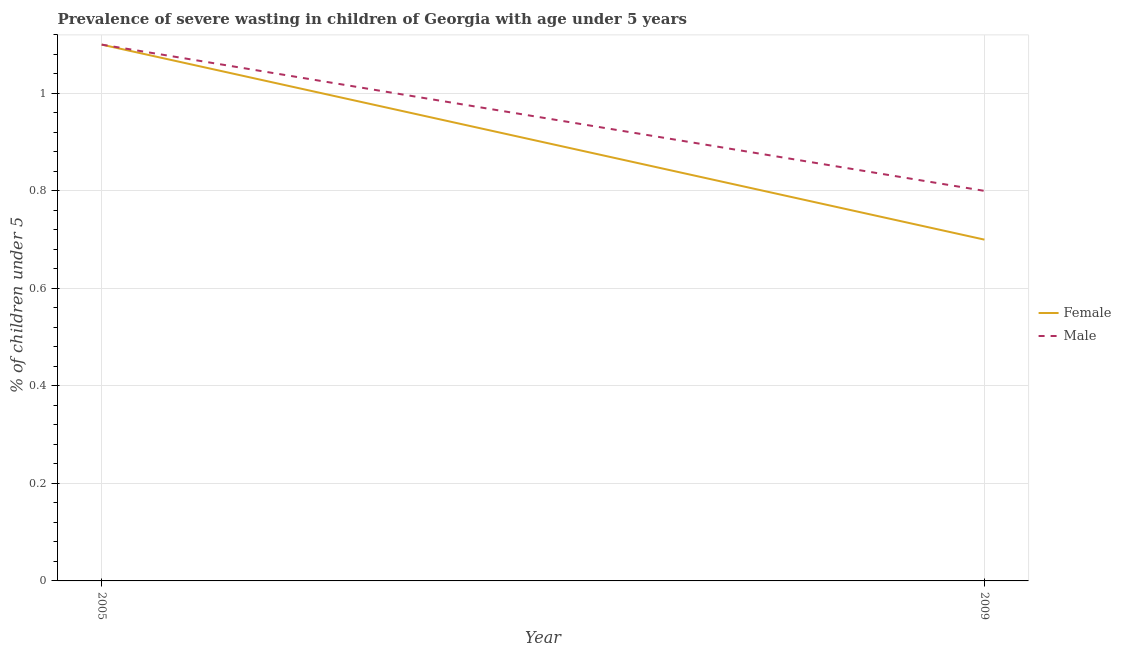How many different coloured lines are there?
Make the answer very short. 2. Does the line corresponding to percentage of undernourished female children intersect with the line corresponding to percentage of undernourished male children?
Provide a short and direct response. Yes. Is the number of lines equal to the number of legend labels?
Your answer should be compact. Yes. What is the percentage of undernourished female children in 2009?
Give a very brief answer. 0.7. Across all years, what is the maximum percentage of undernourished female children?
Make the answer very short. 1.1. Across all years, what is the minimum percentage of undernourished female children?
Provide a short and direct response. 0.7. What is the total percentage of undernourished male children in the graph?
Your answer should be compact. 1.9. What is the difference between the percentage of undernourished female children in 2005 and that in 2009?
Provide a succinct answer. 0.4. What is the difference between the percentage of undernourished female children in 2009 and the percentage of undernourished male children in 2005?
Provide a short and direct response. -0.4. What is the average percentage of undernourished female children per year?
Your answer should be very brief. 0.9. In the year 2005, what is the difference between the percentage of undernourished male children and percentage of undernourished female children?
Give a very brief answer. 0. What is the ratio of the percentage of undernourished male children in 2005 to that in 2009?
Offer a terse response. 1.38. In how many years, is the percentage of undernourished female children greater than the average percentage of undernourished female children taken over all years?
Ensure brevity in your answer.  1. Does the percentage of undernourished male children monotonically increase over the years?
Provide a short and direct response. No. Is the percentage of undernourished male children strictly greater than the percentage of undernourished female children over the years?
Ensure brevity in your answer.  No. How many lines are there?
Offer a terse response. 2. Does the graph contain grids?
Provide a succinct answer. Yes. How many legend labels are there?
Provide a short and direct response. 2. How are the legend labels stacked?
Keep it short and to the point. Vertical. What is the title of the graph?
Keep it short and to the point. Prevalence of severe wasting in children of Georgia with age under 5 years. Does "Largest city" appear as one of the legend labels in the graph?
Offer a very short reply. No. What is the label or title of the X-axis?
Your answer should be compact. Year. What is the label or title of the Y-axis?
Ensure brevity in your answer.   % of children under 5. What is the  % of children under 5 in Female in 2005?
Ensure brevity in your answer.  1.1. What is the  % of children under 5 of Male in 2005?
Keep it short and to the point. 1.1. What is the  % of children under 5 of Female in 2009?
Provide a succinct answer. 0.7. What is the  % of children under 5 in Male in 2009?
Provide a short and direct response. 0.8. Across all years, what is the maximum  % of children under 5 in Female?
Ensure brevity in your answer.  1.1. Across all years, what is the maximum  % of children under 5 of Male?
Ensure brevity in your answer.  1.1. Across all years, what is the minimum  % of children under 5 in Female?
Your response must be concise. 0.7. Across all years, what is the minimum  % of children under 5 of Male?
Offer a very short reply. 0.8. What is the difference between the  % of children under 5 of Female in 2005 and that in 2009?
Your answer should be compact. 0.4. What is the difference between the  % of children under 5 in Female in 2005 and the  % of children under 5 in Male in 2009?
Offer a terse response. 0.3. What is the average  % of children under 5 in Male per year?
Provide a succinct answer. 0.95. In the year 2005, what is the difference between the  % of children under 5 of Female and  % of children under 5 of Male?
Provide a succinct answer. 0. In the year 2009, what is the difference between the  % of children under 5 of Female and  % of children under 5 of Male?
Offer a very short reply. -0.1. What is the ratio of the  % of children under 5 of Female in 2005 to that in 2009?
Offer a terse response. 1.57. What is the ratio of the  % of children under 5 of Male in 2005 to that in 2009?
Make the answer very short. 1.38. What is the difference between the highest and the second highest  % of children under 5 of Male?
Offer a terse response. 0.3. What is the difference between the highest and the lowest  % of children under 5 in Female?
Ensure brevity in your answer.  0.4. 